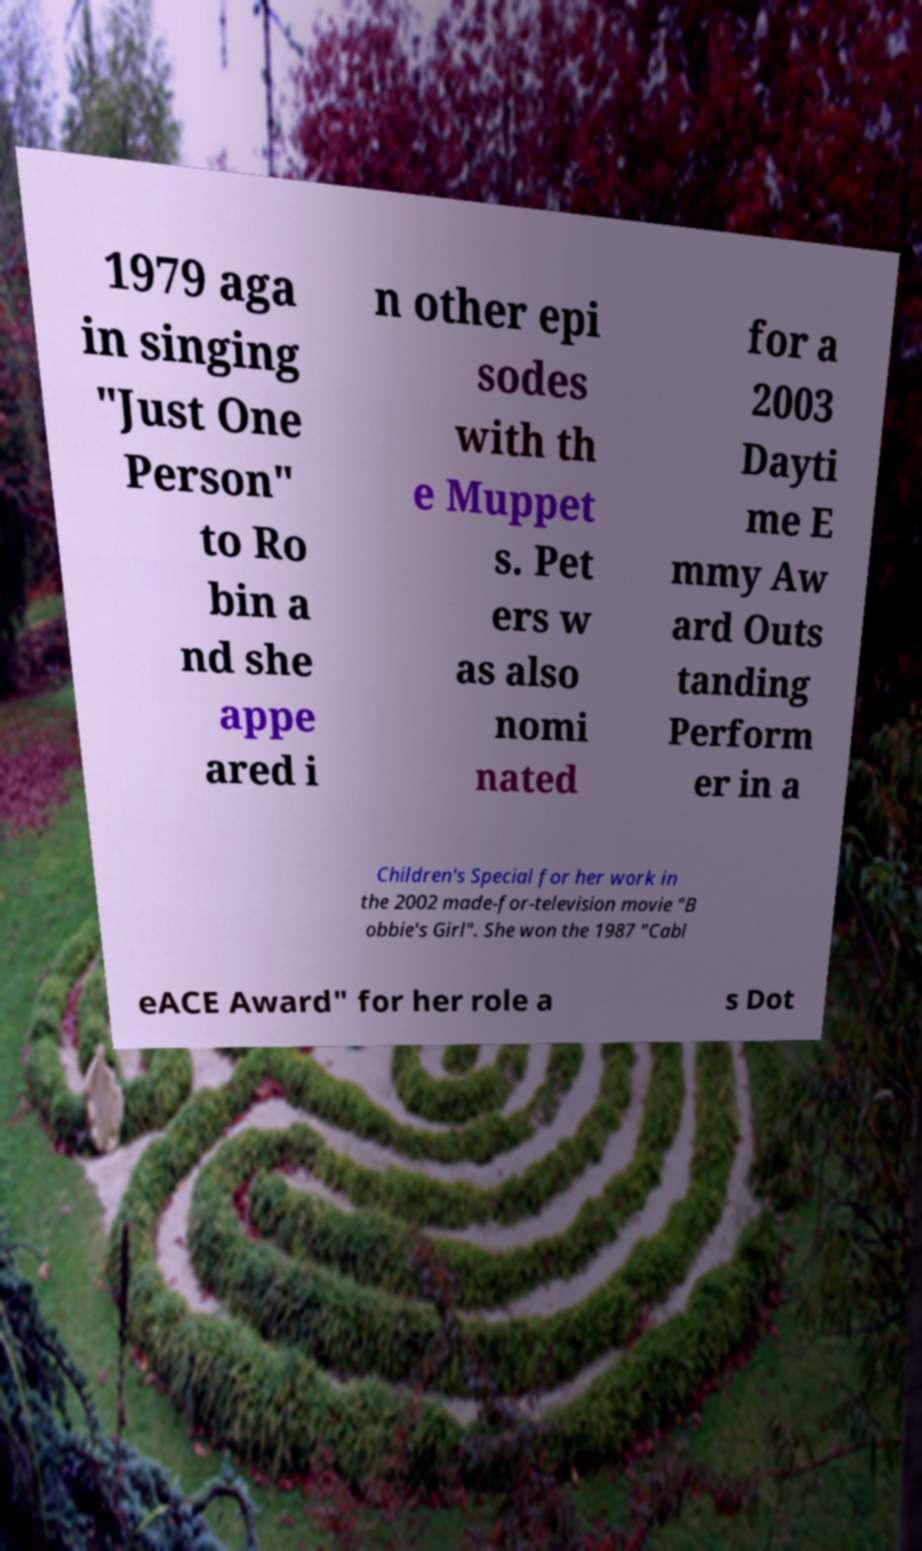Could you assist in decoding the text presented in this image and type it out clearly? 1979 aga in singing "Just One Person" to Ro bin a nd she appe ared i n other epi sodes with th e Muppet s. Pet ers w as also nomi nated for a 2003 Dayti me E mmy Aw ard Outs tanding Perform er in a Children's Special for her work in the 2002 made-for-television movie "B obbie's Girl". She won the 1987 "Cabl eACE Award" for her role a s Dot 